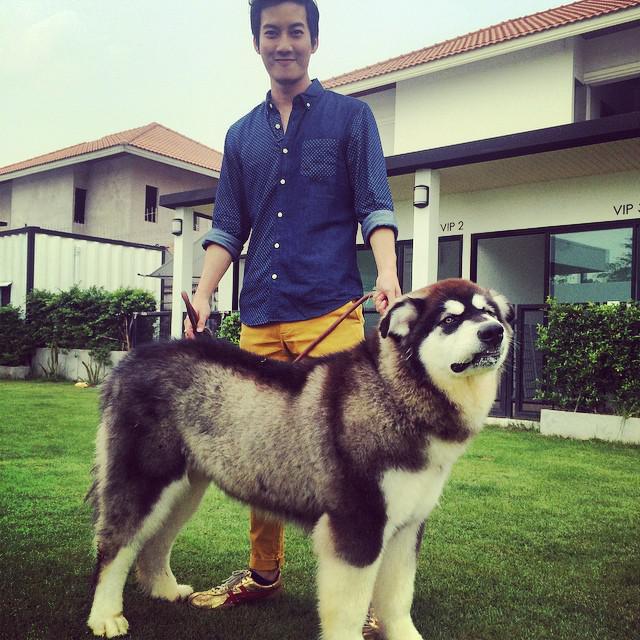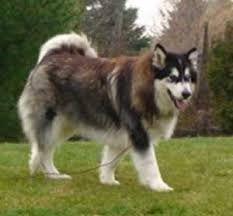The first image is the image on the left, the second image is the image on the right. Given the left and right images, does the statement "The left and right image contains the same number of huskies." hold true? Answer yes or no. Yes. The first image is the image on the left, the second image is the image on the right. Given the left and right images, does the statement "The right image features one person standing behind a dog standing in profile, and the left image includes a person crouching behind a dog." hold true? Answer yes or no. No. 